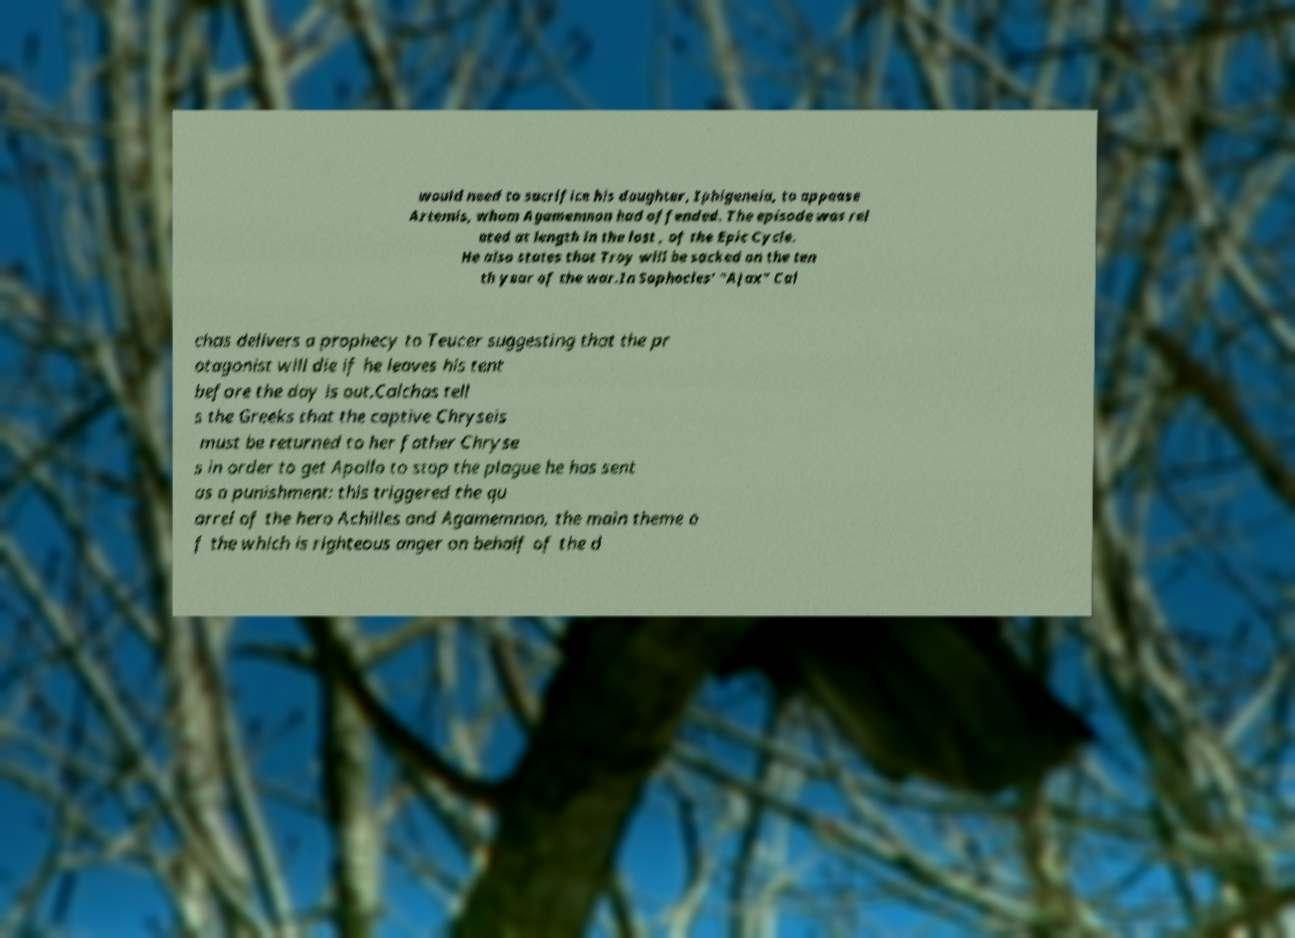Could you assist in decoding the text presented in this image and type it out clearly? would need to sacrifice his daughter, Iphigeneia, to appease Artemis, whom Agamemnon had offended. The episode was rel ated at length in the lost , of the Epic Cycle. He also states that Troy will be sacked on the ten th year of the war.In Sophocles' "Ajax" Cal chas delivers a prophecy to Teucer suggesting that the pr otagonist will die if he leaves his tent before the day is out.Calchas tell s the Greeks that the captive Chryseis must be returned to her father Chryse s in order to get Apollo to stop the plague he has sent as a punishment: this triggered the qu arrel of the hero Achilles and Agamemnon, the main theme o f the which is righteous anger on behalf of the d 